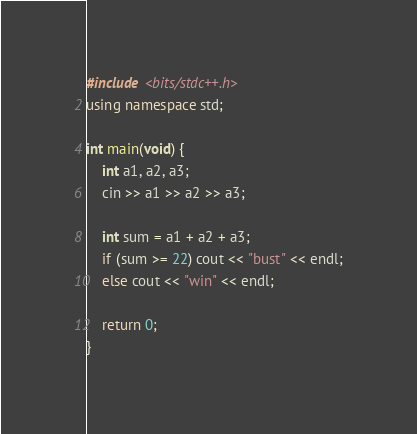Convert code to text. <code><loc_0><loc_0><loc_500><loc_500><_C++_>#include <bits/stdc++.h>
using namespace std;

int main(void) {
    int a1, a2, a3;
    cin >> a1 >> a2 >> a3;

    int sum = a1 + a2 + a3;
    if (sum >= 22) cout << "bust" << endl;
    else cout << "win" << endl;

    return 0;
}</code> 